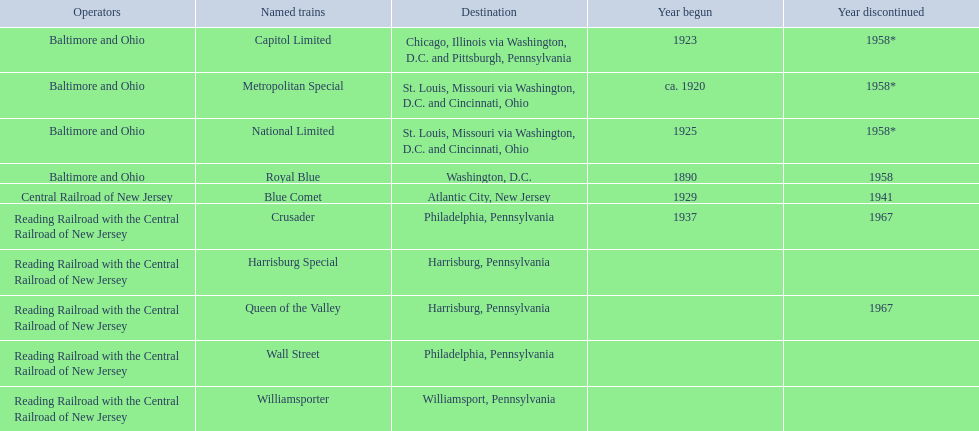What places are featured from the central railroad of new jersey terminal? Chicago, Illinois via Washington, D.C. and Pittsburgh, Pennsylvania, St. Louis, Missouri via Washington, D.C. and Cincinnati, Ohio, St. Louis, Missouri via Washington, D.C. and Cincinnati, Ohio, Washington, D.C., Atlantic City, New Jersey, Philadelphia, Pennsylvania, Harrisburg, Pennsylvania, Harrisburg, Pennsylvania, Philadelphia, Pennsylvania, Williamsport, Pennsylvania. Which of these places is featured first? Chicago, Illinois via Washington, D.C. and Pittsburgh, Pennsylvania. 